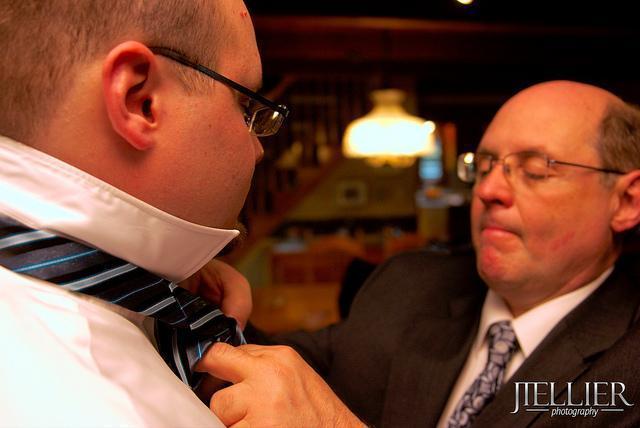How many ties are visible?
Give a very brief answer. 2. How many people can be seen?
Give a very brief answer. 2. How many cups are being held by a person?
Give a very brief answer. 0. 